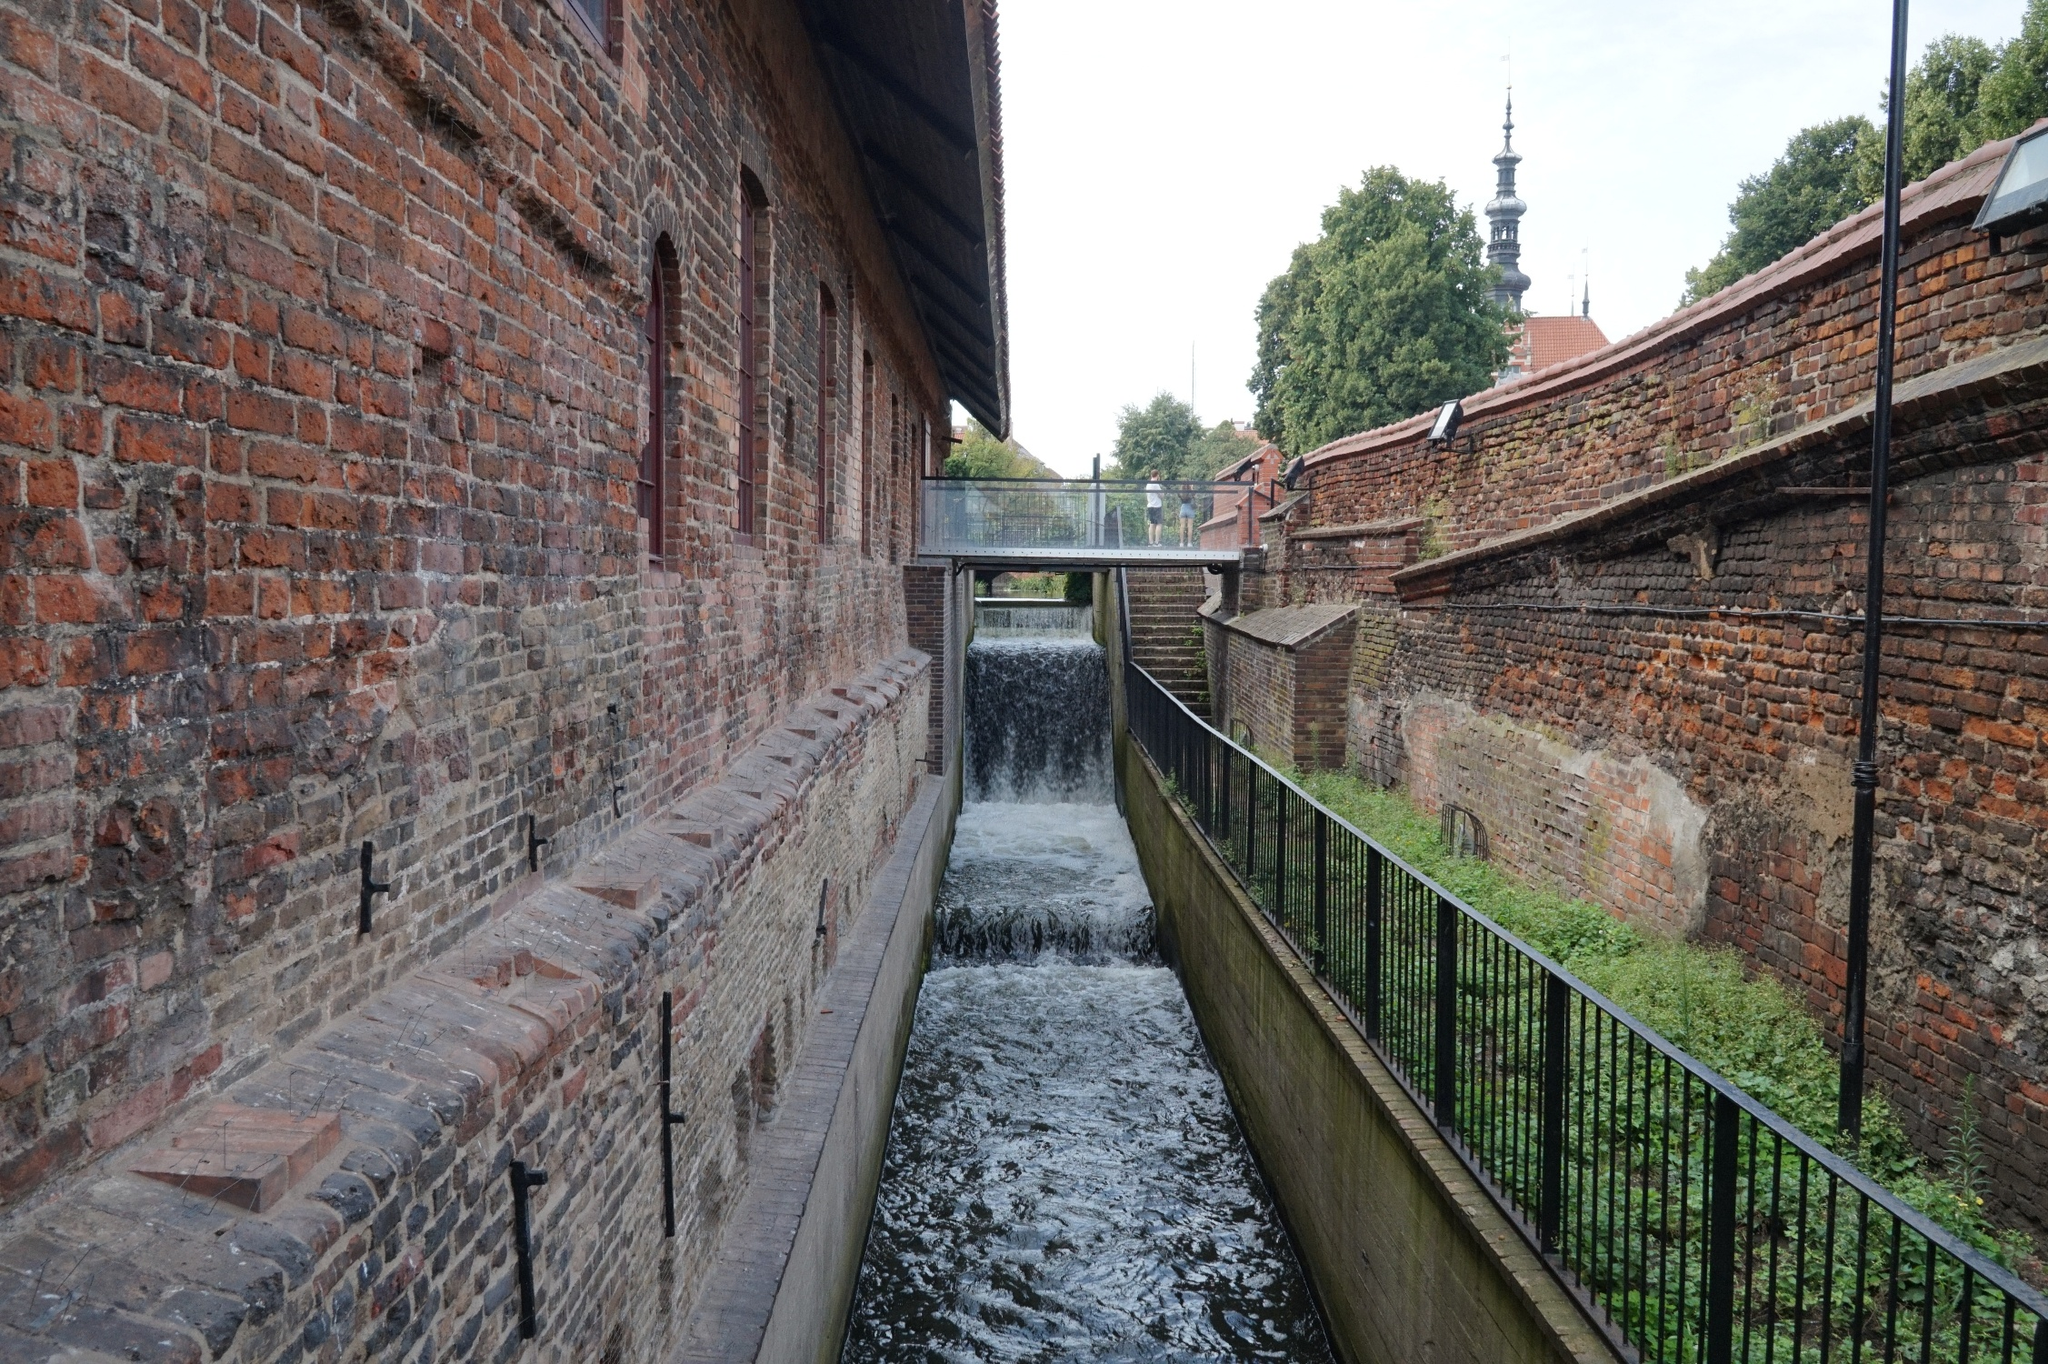Describe a realistic scenario that might be happening in this image. In this scenario, a couple is taking a leisurely walk along the wooden walkway beside the canal. It's a crisp autumn morning, and the air is filled with the gentle sounds of the small waterfall. They pause to admire the historical architecture around them, mapping out their day which includes exploring the nearby historical sites and enjoying a warm cup of coffee at a local café. The setting provides them a quiet respite from the hustle and bustle of everyday life, allowing them to connect and share meaningful moments. 